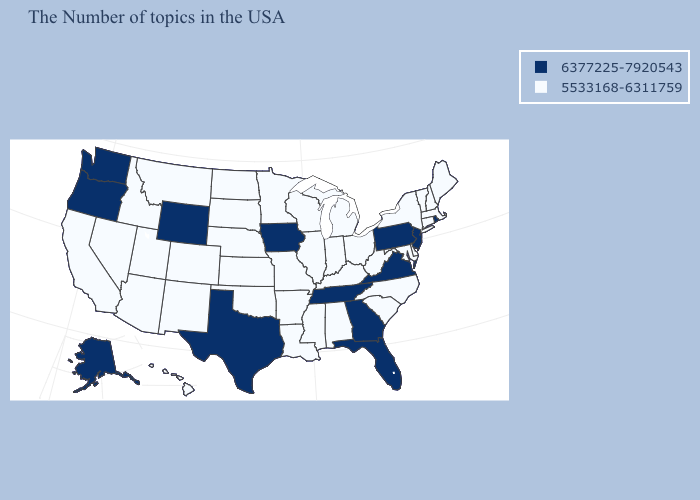What is the value of Delaware?
Short answer required. 5533168-6311759. Which states hav the highest value in the Northeast?
Keep it brief. Rhode Island, New Jersey, Pennsylvania. What is the value of Wyoming?
Quick response, please. 6377225-7920543. What is the value of Ohio?
Quick response, please. 5533168-6311759. Name the states that have a value in the range 6377225-7920543?
Quick response, please. Rhode Island, New Jersey, Pennsylvania, Virginia, Florida, Georgia, Tennessee, Iowa, Texas, Wyoming, Washington, Oregon, Alaska. What is the lowest value in the Northeast?
Give a very brief answer. 5533168-6311759. Name the states that have a value in the range 5533168-6311759?
Short answer required. Maine, Massachusetts, New Hampshire, Vermont, Connecticut, New York, Delaware, Maryland, North Carolina, South Carolina, West Virginia, Ohio, Michigan, Kentucky, Indiana, Alabama, Wisconsin, Illinois, Mississippi, Louisiana, Missouri, Arkansas, Minnesota, Kansas, Nebraska, Oklahoma, South Dakota, North Dakota, Colorado, New Mexico, Utah, Montana, Arizona, Idaho, Nevada, California, Hawaii. Name the states that have a value in the range 5533168-6311759?
Keep it brief. Maine, Massachusetts, New Hampshire, Vermont, Connecticut, New York, Delaware, Maryland, North Carolina, South Carolina, West Virginia, Ohio, Michigan, Kentucky, Indiana, Alabama, Wisconsin, Illinois, Mississippi, Louisiana, Missouri, Arkansas, Minnesota, Kansas, Nebraska, Oklahoma, South Dakota, North Dakota, Colorado, New Mexico, Utah, Montana, Arizona, Idaho, Nevada, California, Hawaii. Among the states that border Louisiana , which have the highest value?
Short answer required. Texas. Name the states that have a value in the range 5533168-6311759?
Concise answer only. Maine, Massachusetts, New Hampshire, Vermont, Connecticut, New York, Delaware, Maryland, North Carolina, South Carolina, West Virginia, Ohio, Michigan, Kentucky, Indiana, Alabama, Wisconsin, Illinois, Mississippi, Louisiana, Missouri, Arkansas, Minnesota, Kansas, Nebraska, Oklahoma, South Dakota, North Dakota, Colorado, New Mexico, Utah, Montana, Arizona, Idaho, Nevada, California, Hawaii. Name the states that have a value in the range 5533168-6311759?
Quick response, please. Maine, Massachusetts, New Hampshire, Vermont, Connecticut, New York, Delaware, Maryland, North Carolina, South Carolina, West Virginia, Ohio, Michigan, Kentucky, Indiana, Alabama, Wisconsin, Illinois, Mississippi, Louisiana, Missouri, Arkansas, Minnesota, Kansas, Nebraska, Oklahoma, South Dakota, North Dakota, Colorado, New Mexico, Utah, Montana, Arizona, Idaho, Nevada, California, Hawaii. What is the value of Kentucky?
Give a very brief answer. 5533168-6311759. Does the map have missing data?
Answer briefly. No. What is the highest value in the USA?
Be succinct. 6377225-7920543. Among the states that border Connecticut , does New York have the lowest value?
Concise answer only. Yes. 